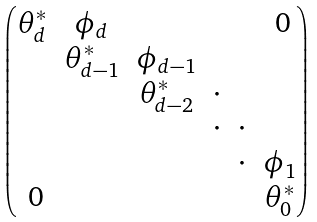Convert formula to latex. <formula><loc_0><loc_0><loc_500><loc_500>\begin{pmatrix} \theta ^ { * } _ { d } & \phi _ { d } & & & & \text { 0} \\ & \theta ^ { * } _ { d - 1 } & \phi _ { d - 1 } \\ & & \theta ^ { * } _ { d - 2 } & \cdot \\ & & & \cdot & \cdot \\ & & & & \cdot & \phi _ { 1 } \\ \text { 0} & & & & & \theta ^ { * } _ { 0 } \end{pmatrix}</formula> 